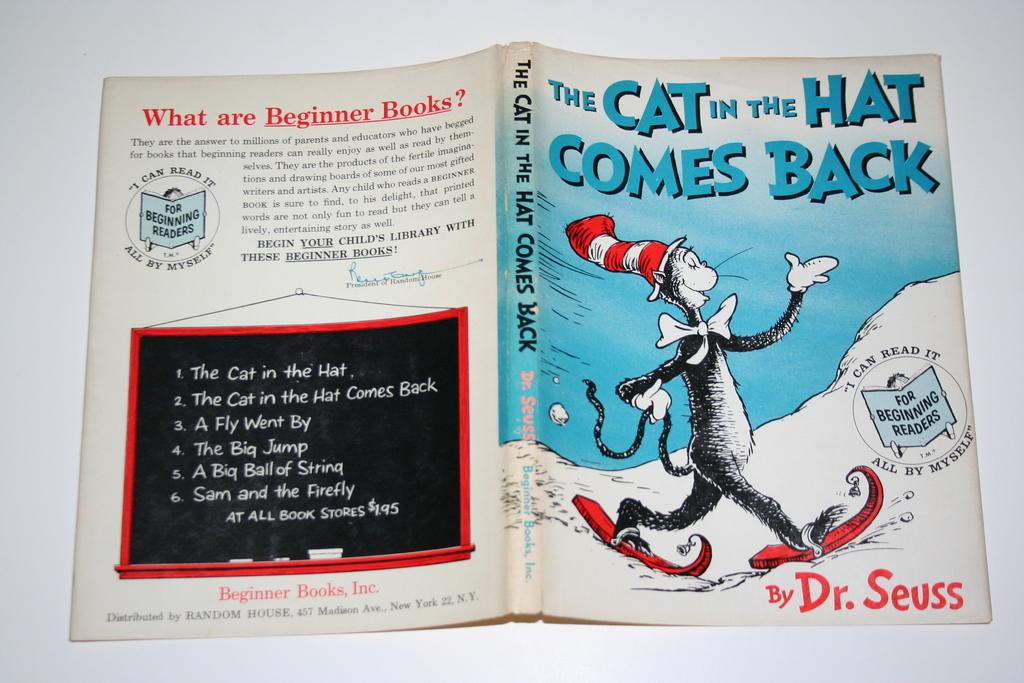What object can be seen in the image? There is a book in the image. Where is the book located? The book is on a white surface. What can be found on the book? There is writing on the book. How many feet are visible on the book in the image? There are no feet visible on the book in the image, as books do not have feet. 